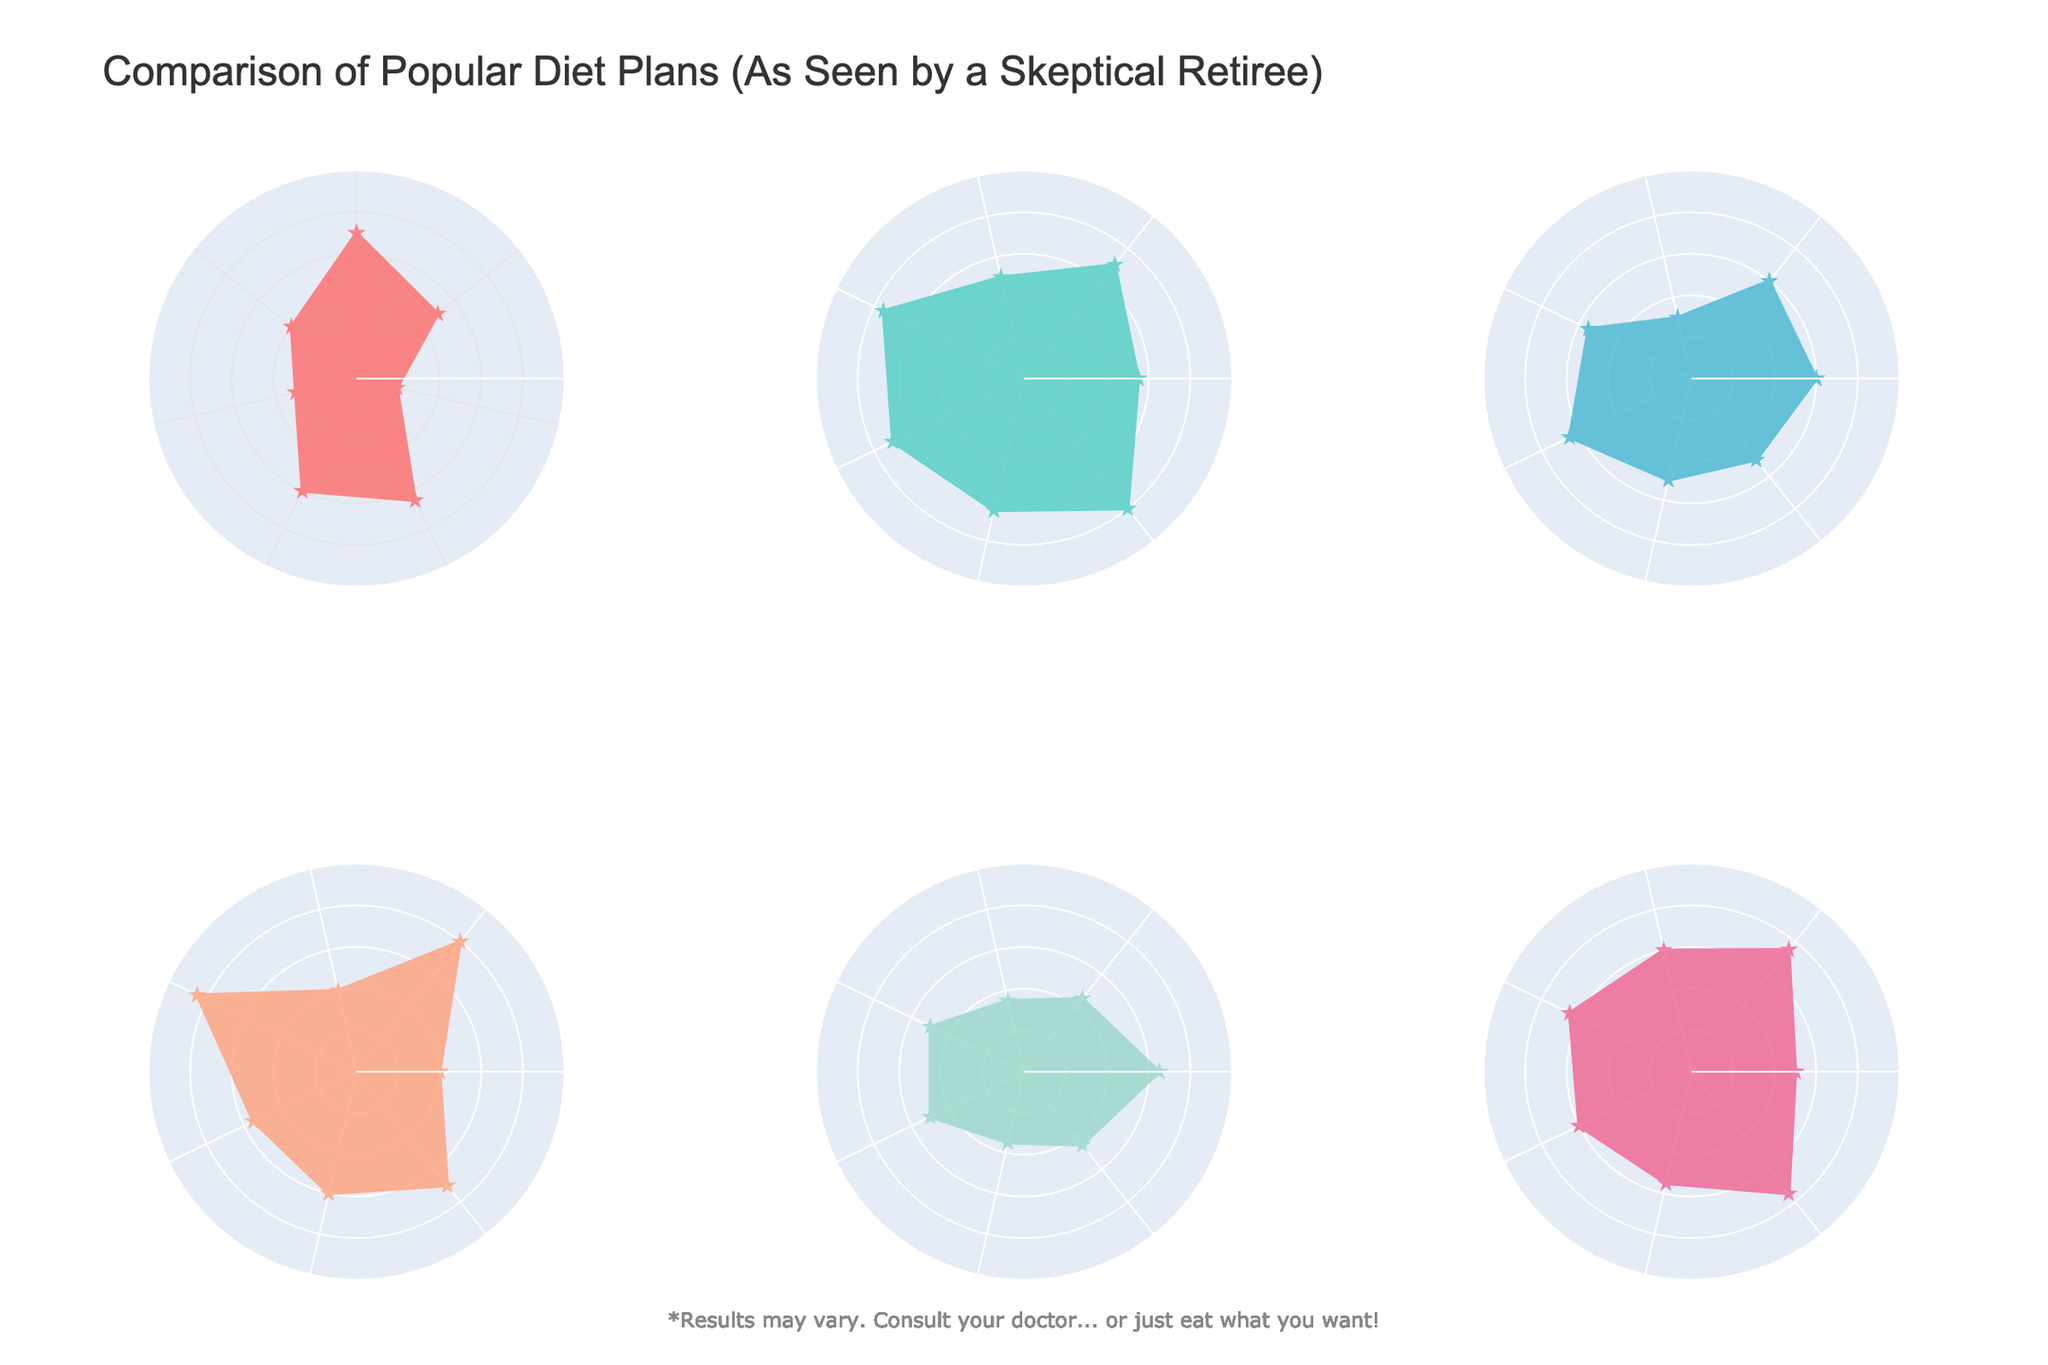What diet plan has the highest adherence score? Look at the adherence scores on the radar charts for each diet plan and identify the highest value. The Vegan diet has an adherence score of 80, the highest among all plans.
Answer: Vegan Which diet plan shows the lowest impact on social life? Examine the social life impact scores for each diet plan and identify the lowest value. Keto has a score of 30, indicating the lowest impact on social life.
Answer: Keto Compare the energy levels of Paleo and Vegan. Which one is higher? Look at the energy levels scores for Paleo (65) and Vegan (55) in their respective charts. Paleo has a higher energy level score.
Answer: Paleo What is the difference in health benefits between Mediterranean and Atkins diets? Refer to the health benefits scores for Mediterranean (75) and Atkins (50), and calculate the difference: 75 - 50.
Answer: 25 Among all the diet plans, which one shows the most balanced performance across all categories? To determine this, observe the radar charts and look for the diet plan where the values appear more evenly spread. Weight Watchers shows fairly balanced scores across all categories without significant extremes.
Answer: Weight Watchers Which diet plan has the most extreme (highest or lowest) values in any category? Identify the diet with the highest and lowest values in any categories. Keto has the lowest cost (20) and Vegan has the highest health benefits (85).
Answer: Keto and Vegan Calculate the average weight loss score across all diet plans. Add the weight loss scores of all diet plans (70 + 55 + 60 + 40 + 65 + 50) and divide by 6. The result is (70+55+60+40+65+50) / 6 = 56.67.
Answer: 56.67 Which diet plan has a higher cost score: Paleo or Mediterranean? Look at the cost scores for Paleo (30) and Mediterranean (50) in their charts. Mediterranean has the higher score.
Answer: Mediterranean If you sum up the sustainability scores for Keto and Paleo, what would be the total? Find the sustainability scores for Keto (40) and Paleo (50). Summing them gives 40 + 50.
Answer: 90 Which diet plan appears to have the least health benefits and sustainability combined? Add the health benefits and sustainability scores for each diet plan, then identify the lowest total. Keto: 65+40=105, Mediterranean: 75+80=155, Paleo: 55+50=105, Vegan: 85+70=155, Atkins: 50+45=95, Weight Watchers: 65+75=140. Atkins has the lowest combined score.
Answer: Atkins 